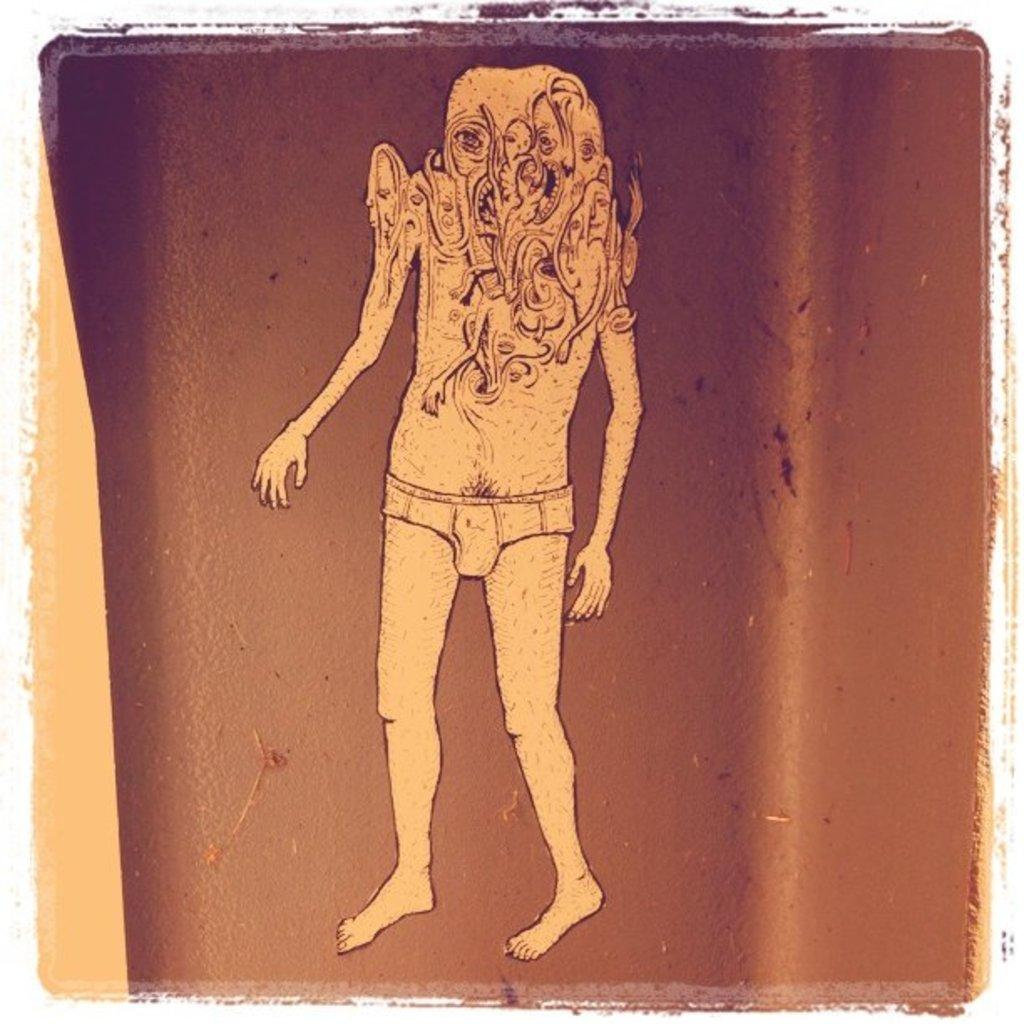What is the main subject of the image? There is a painting in the image. What does the painting appear to depict? The painting appears to depict an alien. What type of toys can be seen in the image? There are no toys present in the image; it features a painting of an alien. What color is the suit worn by the alien in the image? There is no suit worn by the alien in the image, as it is a painting and not a photograph of a real person. 